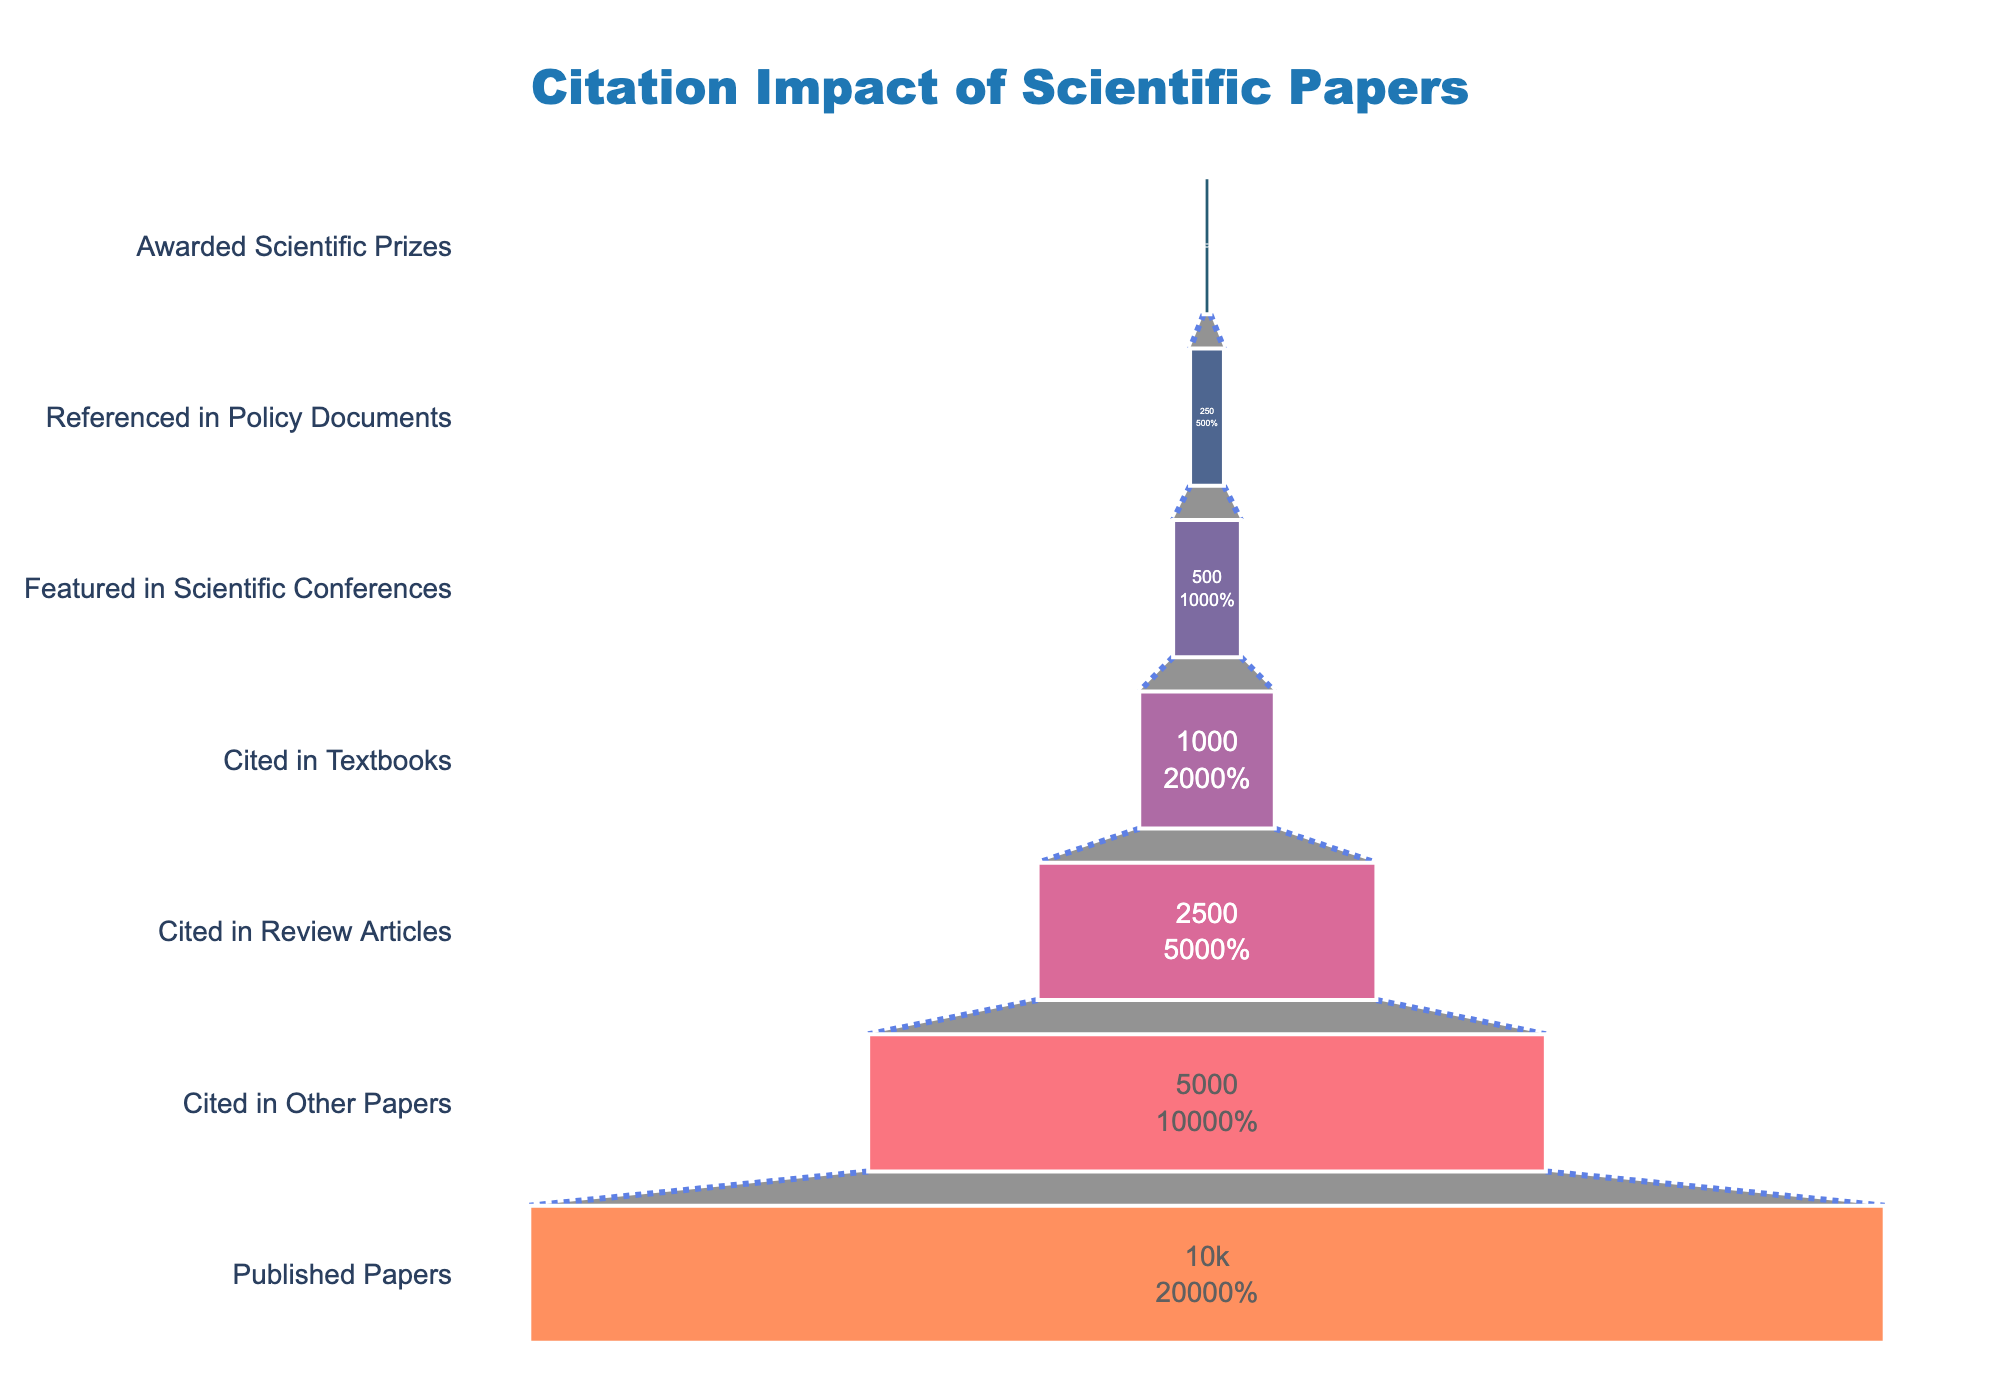What is the title of the figure? The title is typically positioned at the top of the figure. In this case, it's clearly indicated.
Answer: Citation Impact of Scientific Papers How many stages are presented in the funnel chart? By counting the distinct stages from top to bottom of the funnel chart, you can determine the number of stages.
Answer: 7 Which stage has the highest count? By examining the values associated with each stage, the stage with the largest count is identified.
Answer: Published Papers What percentage of published papers are eventually awarded scientific prizes? To find this, divide the count of papers awarded scientific prizes by the count of published papers and multiply by 100. Calculation: (50 / 10000) * 100.
Answer: 0.5% What is the difference in count between papers cited in review articles and those referenced in policy documents? Subtract the count of the referenced in policy documents stage from the cited in review articles stage. Calculation: 2500 - 250.
Answer: 2250 What stage has the lowest count and what is that count? By identifying the stage at the bottom of the funnel, the one with the smallest count is found.
Answer: Awarded Scientific Prizes, 50 How many papers make it to at least the "Cited in Textbooks" stage? The number at the "Cited in Textbooks" stage directly represents this count.
Answer: 1000 Which stage has half the count of the "Cited in Other Papers" stage? Determine half of 5000 (i.e., 5000 / 2) and identify the stage matching this count.
Answer: Cited in Review Articles What is the cumulative count of papers from the "Featured in Scientific Conferences" stage upwards? Add the counts of papers starting from "Featured in Scientific Conferences" to "Awarded Scientific Prizes". Calculation: 500 + 250 + 50.
Answer: 800 Is the count of papers referenced in policy documents greater than 5% of published papers? Calculate 5% of 10000 and compare with the count of referenced in policy documents. Calculation: 5% of 10000 is 500.
Answer: No 